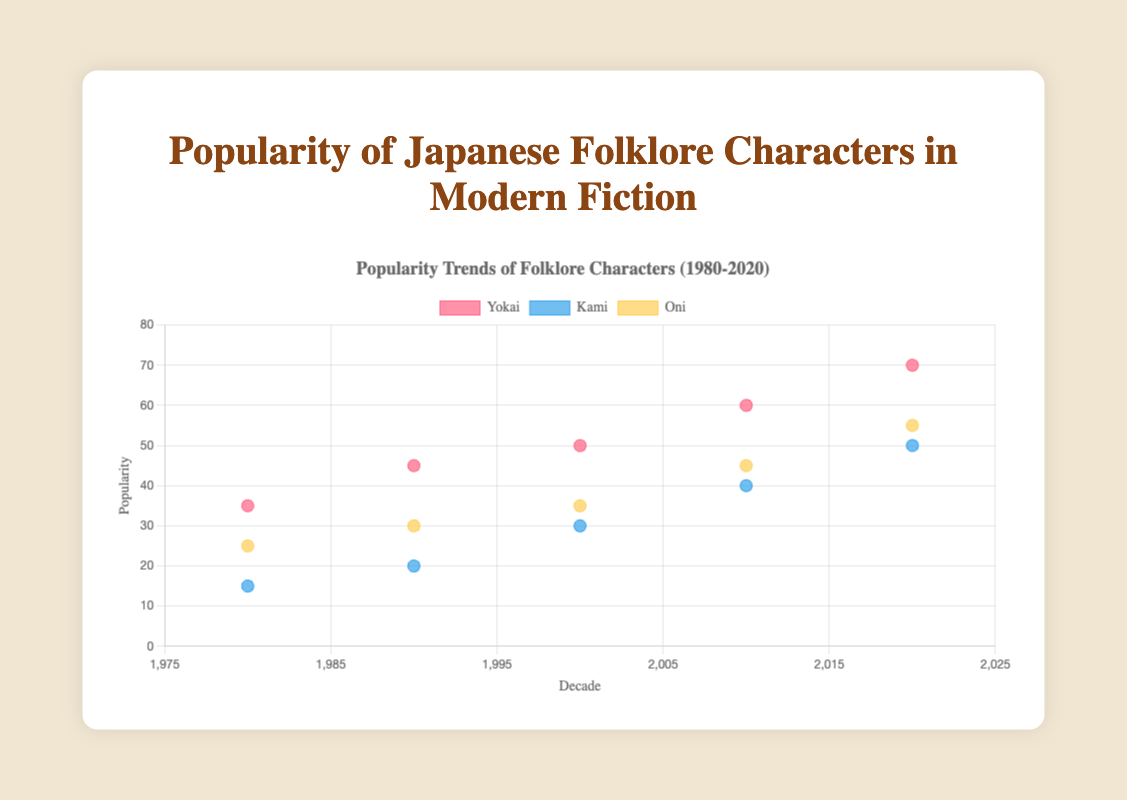What is the title of the figure? The title of the figure is located at the top of the chart and typically describes the main subject of the visualization. Here, the title is "Popularity Trends of Folklore Characters (1980-2020)"
Answer: Popularity Trends of Folklore Characters (1980-2020) Which character type had the highest popularity in the 2020s? To find this, refer to the plotted points for the 2020 decade and compare the y-values. The character type with the highest y-value (popularity) is Yokai with a popularity of 70.
Answer: Yokai How has the popularity of Yokai changed from 1980 to 2020? Look at the plotted points for Yokai from the 1980s to 2020s. In 1980, the popularity was 35, and by 2020 it increased to 70. This shows a steady increase over the decades.
Answer: Increased What is the difference in popularity between Kami and Oni in the year 2000? Check the y-values for Kami and Oni in the 2000 decade. Kami has a popularity of 30, and Oni has a popularity of 35. Subtract the popularity of Kami from Oni: 35 - 30 = 5.
Answer: 5 Which character type shows the steepest increase in popularity from 1980 to 2020? Evaluate the slopes of the trend lines for all character types. Yokai increased from 35 to 70, Kami from 15 to 50, and Oni from 25 to 55. The increase for Yokai is 35, for Kami is 35, and for Oni is 30. Yokai and Kami both have the steepest increase of 35.
Answer: Yokai and Kami What is the average popularity of Kami across the decades given in the data? Sum the popularity values of Kami for all decades and divide by the number of decades. (15 + 20 + 30 + 40 + 50) = 155. There are 5 data points, so 155/5 = 31.
Answer: 31 In which decade did Oni have a popularity of 45? Look for the plotted point of Oni where the y-value is 45. This occurs in the 2010 decade.
Answer: 2010 How many data points are there for each character type? Each character type has data points for the following decades: 1980, 1990, 2000, 2010, and 2020. Since there is one data point for each decade, each character type has 5 data points.
Answer: 5 If you were to describe the overall trend of Kami's popularity, what would you say? Examining the plotted points for Kami over the decades, the popularity increases steadily across each decade from 15 in 1980 to 50 in 2020. Therefore, the trend is a consistent upward trend.
Answer: Increasing steadily 